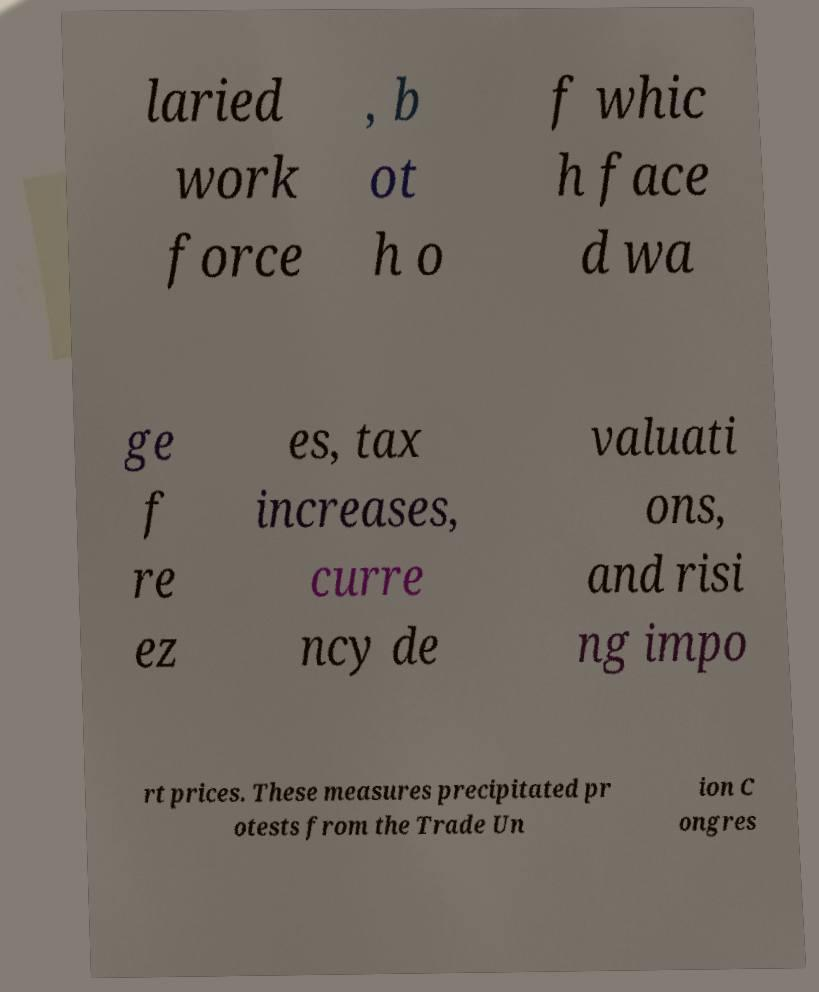What messages or text are displayed in this image? I need them in a readable, typed format. laried work force , b ot h o f whic h face d wa ge f re ez es, tax increases, curre ncy de valuati ons, and risi ng impo rt prices. These measures precipitated pr otests from the Trade Un ion C ongres 